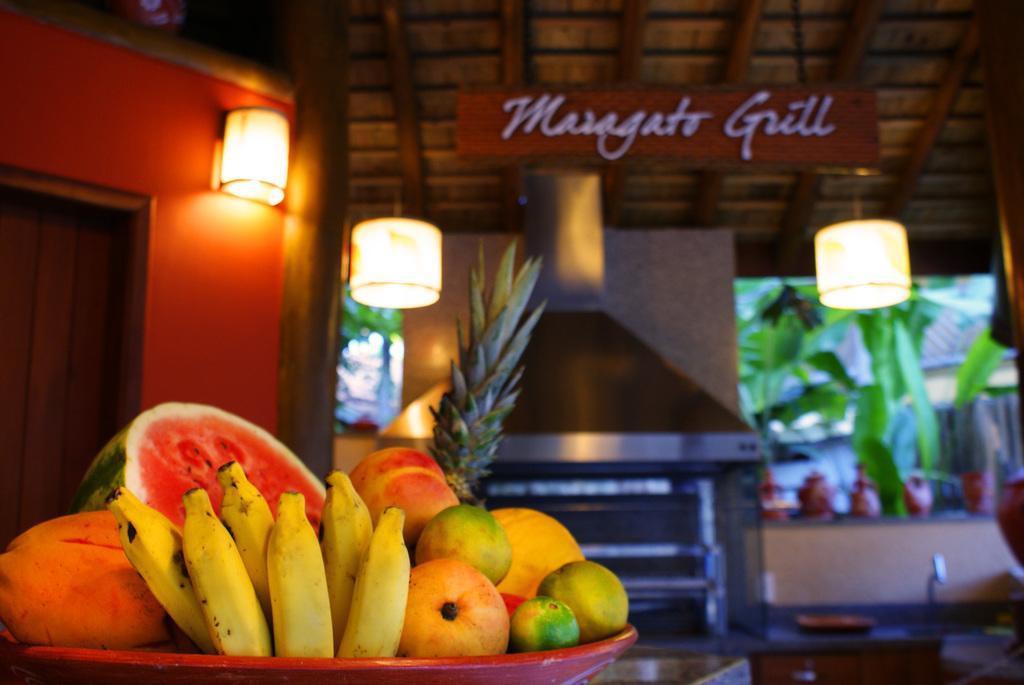Could you give a brief overview of what you see in this image? In the image we can see a plate, red in color. On the plate we can see there are fruits like banana, apple, orange, papaya, watermelon and pineapple. Here we can see lights, board, text, leaves and the background is blurred. 